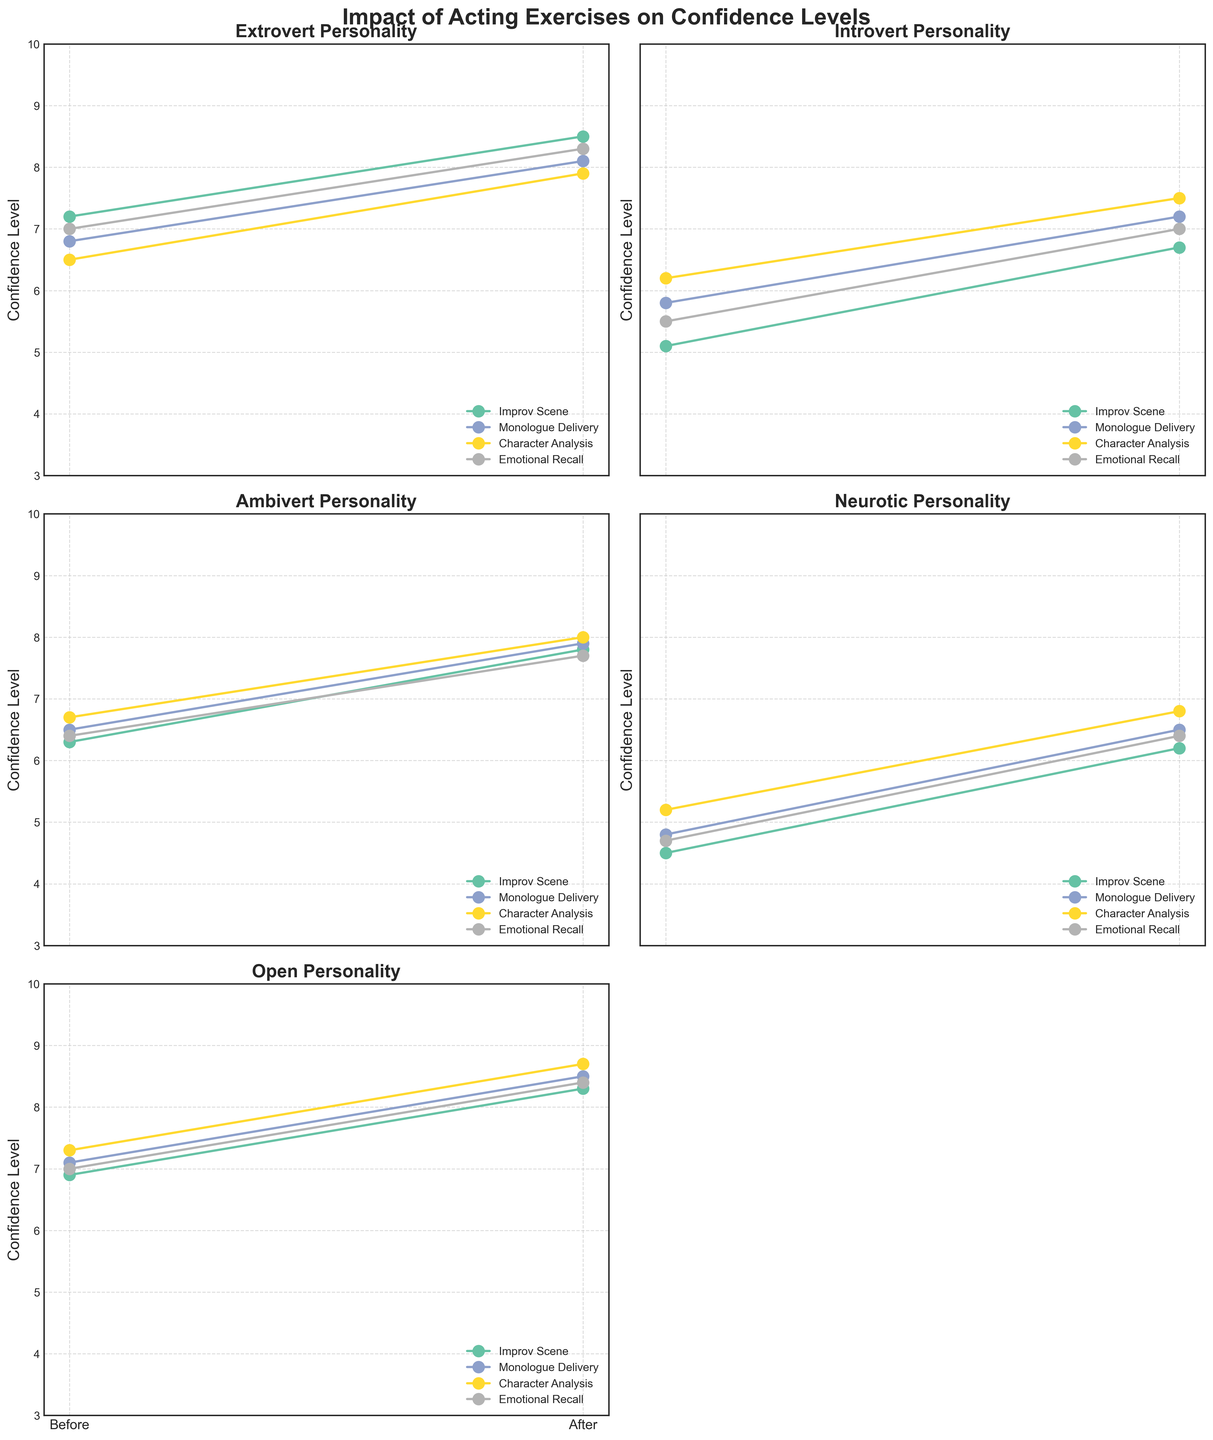What is the title of the figure? The title of the figure is displayed at the top and is often in a larger, bold font. The title consolidates the overall theme and purpose of the figure, making it clear what the visual representation is about. In this case, the title is "Impact of Acting Exercises on Confidence Levels".
Answer: Impact of Acting Exercises on Confidence Levels Which personality type shows the highest initial confidence level in the 'Improv Scene' exercise? To determine the highest initial confidence level for 'Improv Scene', we examine the 'Confidence_Before' values specific to 'Improv Scene' across all personality types. The values are as follows: Extrovert (7.2), Introvert (5.1), Ambivert (6.3), Neurotic (4.5), Open (6.9). The highest value is 7.2, which corresponds to the Extrovert personality.
Answer: Extrovert Which acting exercise resulted in the biggest increase in confidence for the Introvert personality type? To find the biggest increase for Introverts, calculate the difference between 'Confidence_Before' and 'Confidence_After' for each exercise: Improv Scene (6.7-5.1=1.6), Monologue Delivery (7.2-5.8=1.4), Character Analysis (7.5-6.2=1.3), Emotional Recall (7.0-5.5=1.5). The largest increase is 1.6 for the Improv Scene exercise.
Answer: Improv Scene Overall, which personality type underwent the largest average increase in confidence across all exercises? Calculate the average increase for each personality by summing the differences between 'Confidence_Before' and 'Confidence_After' for all exercises and dividing by the number of exercises: 
- Extrovert: (8.5-7.2 + 8.1-6.8 + 7.9-6.5 + 8.3-7.0) / 4 = 1.35
- Introvert: (6.7-5.1 + 7.2-5.8 + 7.5-6.2 + 7.0-5.5) / 4 = 1.525
- Ambivert: (7.8-6.3 + 7.9-6.5 + 8.0-6.7 + 7.7-6.4) / 4 = 1.375
- Neurotic: (6.2-4.5 + 6.5-4.8 + 6.8-5.2 + 6.4-4.7) / 4 = 1.475
- Open: (8.3-6.9 + 8.5-7.1 + 8.7-7.3 + 8.4-7.0) / 4 = 1.4
The Introvert personality type has the highest average increase of 1.525.
Answer: Introvert Which acting exercise shows a consistent increase in confidence for all personality types? To find a consistent increase, observe which exercise shows a higher confidence after the exercise compared to before for all personality types. All exercises show an increase, but we need one consistent across all types. Improv Scene (Extrovert: 1.3, Introvert: 1.6, Ambivert: 1.5, Neurotic: 1.7, Open: 1.4) fits this criterion.
Answer: Improv Scene What is the range of the confidence levels before participating in 'Character Analysis' for all personality types? The range is determined by finding the difference between the highest and lowest values of 'Confidence_Before' for 'Character Analysis'. The values are: Extrovert (6.5), Introvert (6.2), Ambivert (6.7), Neurotic (5.2), Open (7.3). The highest value is 7.3 and the lowest is 5.2, so the range is 7.3 - 5.2 = 2.1.
Answer: 2.1 Which personality type experienced the smallest improvement in confidence level after the 'Emotional Recall' exercise? Calculate the improvement for each personality in 'Emotional Recall': Extrovert (8.3-7.0=1.3), Introvert (7.0-5.5=1.5), Ambivert (7.7-6.4=1.3), Neurotic (6.4-4.7=1.7), Open (8.4-7.0=1.4). The shared smallest improvement is 1.3, observed in both Extroverts and Ambiverts.
Answer: Extrovert and Ambivert 